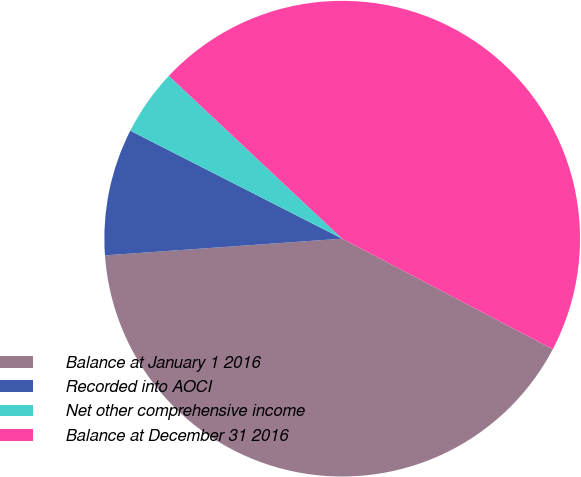Convert chart to OTSL. <chart><loc_0><loc_0><loc_500><loc_500><pie_chart><fcel>Balance at January 1 2016<fcel>Recorded into AOCI<fcel>Net other comprehensive income<fcel>Balance at December 31 2016<nl><fcel>41.19%<fcel>8.62%<fcel>4.5%<fcel>45.69%<nl></chart> 